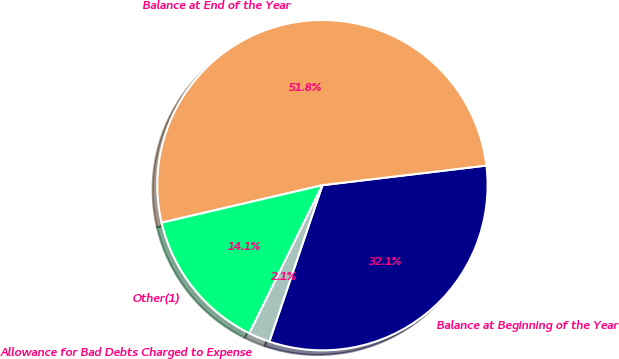Convert chart to OTSL. <chart><loc_0><loc_0><loc_500><loc_500><pie_chart><fcel>Balance at Beginning of the Year<fcel>Balance at End of the Year<fcel>Other(1)<fcel>Allowance for Bad Debts Charged to Expense<nl><fcel>32.11%<fcel>51.75%<fcel>14.06%<fcel>2.08%<nl></chart> 